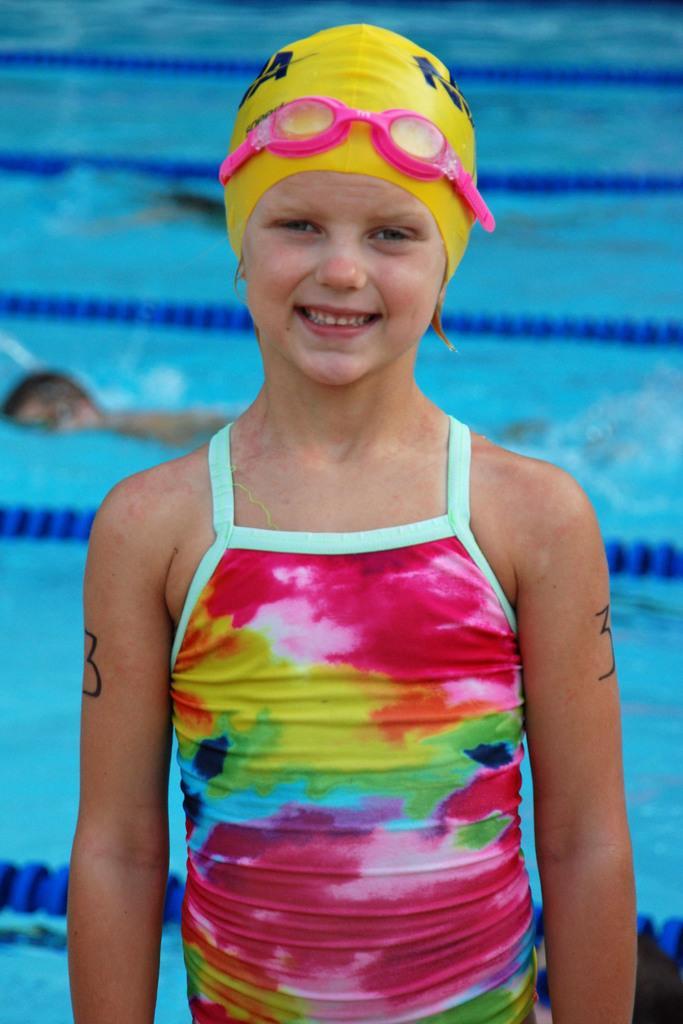Can you describe this image briefly? In this image there is a girl standing and smiling, and in the background there are two persons swimming in the pool,and there are swimming pool lane ropes. 